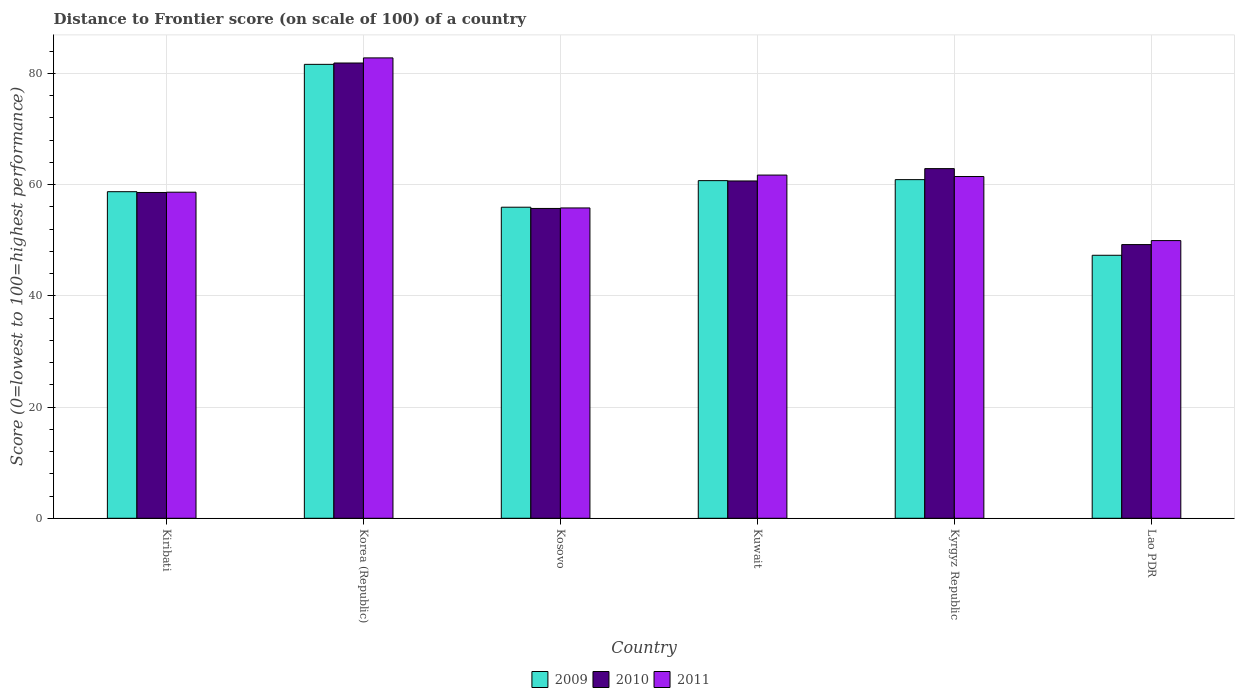How many different coloured bars are there?
Your response must be concise. 3. Are the number of bars per tick equal to the number of legend labels?
Your response must be concise. Yes. Are the number of bars on each tick of the X-axis equal?
Your answer should be very brief. Yes. How many bars are there on the 2nd tick from the left?
Keep it short and to the point. 3. What is the distance to frontier score of in 2011 in Lao PDR?
Your answer should be very brief. 49.93. Across all countries, what is the maximum distance to frontier score of in 2009?
Give a very brief answer. 81.62. Across all countries, what is the minimum distance to frontier score of in 2011?
Offer a very short reply. 49.93. In which country was the distance to frontier score of in 2011 minimum?
Your response must be concise. Lao PDR. What is the total distance to frontier score of in 2009 in the graph?
Provide a short and direct response. 365.16. What is the difference between the distance to frontier score of in 2011 in Kiribati and that in Kuwait?
Your answer should be very brief. -3.08. What is the difference between the distance to frontier score of in 2010 in Lao PDR and the distance to frontier score of in 2009 in Kyrgyz Republic?
Ensure brevity in your answer.  -11.68. What is the average distance to frontier score of in 2009 per country?
Offer a terse response. 60.86. What is the difference between the distance to frontier score of of/in 2009 and distance to frontier score of of/in 2011 in Lao PDR?
Your answer should be very brief. -2.64. In how many countries, is the distance to frontier score of in 2011 greater than 24?
Keep it short and to the point. 6. What is the ratio of the distance to frontier score of in 2010 in Kosovo to that in Kuwait?
Keep it short and to the point. 0.92. Is the distance to frontier score of in 2009 in Kiribati less than that in Kuwait?
Offer a very short reply. Yes. What is the difference between the highest and the second highest distance to frontier score of in 2009?
Give a very brief answer. 20.73. What is the difference between the highest and the lowest distance to frontier score of in 2009?
Give a very brief answer. 34.33. Is the sum of the distance to frontier score of in 2011 in Kiribati and Kyrgyz Republic greater than the maximum distance to frontier score of in 2009 across all countries?
Your answer should be very brief. Yes. What does the 1st bar from the right in Korea (Republic) represents?
Ensure brevity in your answer.  2011. How many countries are there in the graph?
Offer a very short reply. 6. Are the values on the major ticks of Y-axis written in scientific E-notation?
Ensure brevity in your answer.  No. Where does the legend appear in the graph?
Offer a terse response. Bottom center. How many legend labels are there?
Make the answer very short. 3. How are the legend labels stacked?
Ensure brevity in your answer.  Horizontal. What is the title of the graph?
Offer a terse response. Distance to Frontier score (on scale of 100) of a country. What is the label or title of the X-axis?
Offer a very short reply. Country. What is the label or title of the Y-axis?
Provide a succinct answer. Score (0=lowest to 100=highest performance). What is the Score (0=lowest to 100=highest performance) of 2009 in Kiribati?
Provide a short and direct response. 58.72. What is the Score (0=lowest to 100=highest performance) of 2010 in Kiribati?
Your response must be concise. 58.58. What is the Score (0=lowest to 100=highest performance) in 2011 in Kiribati?
Your answer should be compact. 58.63. What is the Score (0=lowest to 100=highest performance) in 2009 in Korea (Republic)?
Offer a very short reply. 81.62. What is the Score (0=lowest to 100=highest performance) of 2010 in Korea (Republic)?
Your response must be concise. 81.86. What is the Score (0=lowest to 100=highest performance) in 2011 in Korea (Republic)?
Your answer should be compact. 82.78. What is the Score (0=lowest to 100=highest performance) in 2009 in Kosovo?
Your response must be concise. 55.93. What is the Score (0=lowest to 100=highest performance) of 2010 in Kosovo?
Make the answer very short. 55.71. What is the Score (0=lowest to 100=highest performance) of 2011 in Kosovo?
Make the answer very short. 55.8. What is the Score (0=lowest to 100=highest performance) in 2009 in Kuwait?
Give a very brief answer. 60.71. What is the Score (0=lowest to 100=highest performance) of 2010 in Kuwait?
Your response must be concise. 60.65. What is the Score (0=lowest to 100=highest performance) of 2011 in Kuwait?
Provide a succinct answer. 61.71. What is the Score (0=lowest to 100=highest performance) in 2009 in Kyrgyz Republic?
Offer a terse response. 60.89. What is the Score (0=lowest to 100=highest performance) in 2010 in Kyrgyz Republic?
Your answer should be compact. 62.87. What is the Score (0=lowest to 100=highest performance) in 2011 in Kyrgyz Republic?
Your answer should be very brief. 61.45. What is the Score (0=lowest to 100=highest performance) of 2009 in Lao PDR?
Make the answer very short. 47.29. What is the Score (0=lowest to 100=highest performance) of 2010 in Lao PDR?
Offer a terse response. 49.21. What is the Score (0=lowest to 100=highest performance) of 2011 in Lao PDR?
Your answer should be very brief. 49.93. Across all countries, what is the maximum Score (0=lowest to 100=highest performance) in 2009?
Your response must be concise. 81.62. Across all countries, what is the maximum Score (0=lowest to 100=highest performance) in 2010?
Your answer should be compact. 81.86. Across all countries, what is the maximum Score (0=lowest to 100=highest performance) of 2011?
Your response must be concise. 82.78. Across all countries, what is the minimum Score (0=lowest to 100=highest performance) in 2009?
Provide a succinct answer. 47.29. Across all countries, what is the minimum Score (0=lowest to 100=highest performance) in 2010?
Ensure brevity in your answer.  49.21. Across all countries, what is the minimum Score (0=lowest to 100=highest performance) of 2011?
Provide a succinct answer. 49.93. What is the total Score (0=lowest to 100=highest performance) of 2009 in the graph?
Offer a terse response. 365.16. What is the total Score (0=lowest to 100=highest performance) in 2010 in the graph?
Ensure brevity in your answer.  368.88. What is the total Score (0=lowest to 100=highest performance) in 2011 in the graph?
Provide a succinct answer. 370.3. What is the difference between the Score (0=lowest to 100=highest performance) in 2009 in Kiribati and that in Korea (Republic)?
Your answer should be compact. -22.9. What is the difference between the Score (0=lowest to 100=highest performance) in 2010 in Kiribati and that in Korea (Republic)?
Offer a terse response. -23.28. What is the difference between the Score (0=lowest to 100=highest performance) in 2011 in Kiribati and that in Korea (Republic)?
Ensure brevity in your answer.  -24.15. What is the difference between the Score (0=lowest to 100=highest performance) in 2009 in Kiribati and that in Kosovo?
Your answer should be compact. 2.79. What is the difference between the Score (0=lowest to 100=highest performance) in 2010 in Kiribati and that in Kosovo?
Provide a short and direct response. 2.87. What is the difference between the Score (0=lowest to 100=highest performance) of 2011 in Kiribati and that in Kosovo?
Ensure brevity in your answer.  2.83. What is the difference between the Score (0=lowest to 100=highest performance) of 2009 in Kiribati and that in Kuwait?
Your response must be concise. -1.99. What is the difference between the Score (0=lowest to 100=highest performance) of 2010 in Kiribati and that in Kuwait?
Keep it short and to the point. -2.07. What is the difference between the Score (0=lowest to 100=highest performance) of 2011 in Kiribati and that in Kuwait?
Your answer should be very brief. -3.08. What is the difference between the Score (0=lowest to 100=highest performance) of 2009 in Kiribati and that in Kyrgyz Republic?
Make the answer very short. -2.17. What is the difference between the Score (0=lowest to 100=highest performance) in 2010 in Kiribati and that in Kyrgyz Republic?
Provide a succinct answer. -4.29. What is the difference between the Score (0=lowest to 100=highest performance) of 2011 in Kiribati and that in Kyrgyz Republic?
Make the answer very short. -2.82. What is the difference between the Score (0=lowest to 100=highest performance) in 2009 in Kiribati and that in Lao PDR?
Offer a terse response. 11.43. What is the difference between the Score (0=lowest to 100=highest performance) of 2010 in Kiribati and that in Lao PDR?
Offer a terse response. 9.37. What is the difference between the Score (0=lowest to 100=highest performance) in 2011 in Kiribati and that in Lao PDR?
Provide a short and direct response. 8.7. What is the difference between the Score (0=lowest to 100=highest performance) in 2009 in Korea (Republic) and that in Kosovo?
Give a very brief answer. 25.69. What is the difference between the Score (0=lowest to 100=highest performance) in 2010 in Korea (Republic) and that in Kosovo?
Your answer should be compact. 26.15. What is the difference between the Score (0=lowest to 100=highest performance) in 2011 in Korea (Republic) and that in Kosovo?
Provide a succinct answer. 26.98. What is the difference between the Score (0=lowest to 100=highest performance) in 2009 in Korea (Republic) and that in Kuwait?
Offer a very short reply. 20.91. What is the difference between the Score (0=lowest to 100=highest performance) of 2010 in Korea (Republic) and that in Kuwait?
Ensure brevity in your answer.  21.21. What is the difference between the Score (0=lowest to 100=highest performance) in 2011 in Korea (Republic) and that in Kuwait?
Make the answer very short. 21.07. What is the difference between the Score (0=lowest to 100=highest performance) in 2009 in Korea (Republic) and that in Kyrgyz Republic?
Ensure brevity in your answer.  20.73. What is the difference between the Score (0=lowest to 100=highest performance) in 2010 in Korea (Republic) and that in Kyrgyz Republic?
Your answer should be very brief. 18.99. What is the difference between the Score (0=lowest to 100=highest performance) of 2011 in Korea (Republic) and that in Kyrgyz Republic?
Give a very brief answer. 21.33. What is the difference between the Score (0=lowest to 100=highest performance) of 2009 in Korea (Republic) and that in Lao PDR?
Your answer should be very brief. 34.33. What is the difference between the Score (0=lowest to 100=highest performance) of 2010 in Korea (Republic) and that in Lao PDR?
Your answer should be very brief. 32.65. What is the difference between the Score (0=lowest to 100=highest performance) in 2011 in Korea (Republic) and that in Lao PDR?
Your answer should be compact. 32.85. What is the difference between the Score (0=lowest to 100=highest performance) of 2009 in Kosovo and that in Kuwait?
Your response must be concise. -4.78. What is the difference between the Score (0=lowest to 100=highest performance) in 2010 in Kosovo and that in Kuwait?
Your answer should be compact. -4.94. What is the difference between the Score (0=lowest to 100=highest performance) in 2011 in Kosovo and that in Kuwait?
Give a very brief answer. -5.91. What is the difference between the Score (0=lowest to 100=highest performance) in 2009 in Kosovo and that in Kyrgyz Republic?
Your answer should be very brief. -4.96. What is the difference between the Score (0=lowest to 100=highest performance) of 2010 in Kosovo and that in Kyrgyz Republic?
Give a very brief answer. -7.16. What is the difference between the Score (0=lowest to 100=highest performance) in 2011 in Kosovo and that in Kyrgyz Republic?
Make the answer very short. -5.65. What is the difference between the Score (0=lowest to 100=highest performance) of 2009 in Kosovo and that in Lao PDR?
Provide a succinct answer. 8.64. What is the difference between the Score (0=lowest to 100=highest performance) in 2011 in Kosovo and that in Lao PDR?
Provide a short and direct response. 5.87. What is the difference between the Score (0=lowest to 100=highest performance) in 2009 in Kuwait and that in Kyrgyz Republic?
Offer a terse response. -0.18. What is the difference between the Score (0=lowest to 100=highest performance) of 2010 in Kuwait and that in Kyrgyz Republic?
Your answer should be very brief. -2.22. What is the difference between the Score (0=lowest to 100=highest performance) of 2011 in Kuwait and that in Kyrgyz Republic?
Ensure brevity in your answer.  0.26. What is the difference between the Score (0=lowest to 100=highest performance) of 2009 in Kuwait and that in Lao PDR?
Ensure brevity in your answer.  13.42. What is the difference between the Score (0=lowest to 100=highest performance) of 2010 in Kuwait and that in Lao PDR?
Your answer should be compact. 11.44. What is the difference between the Score (0=lowest to 100=highest performance) in 2011 in Kuwait and that in Lao PDR?
Your answer should be very brief. 11.78. What is the difference between the Score (0=lowest to 100=highest performance) in 2009 in Kyrgyz Republic and that in Lao PDR?
Provide a succinct answer. 13.6. What is the difference between the Score (0=lowest to 100=highest performance) of 2010 in Kyrgyz Republic and that in Lao PDR?
Provide a short and direct response. 13.66. What is the difference between the Score (0=lowest to 100=highest performance) of 2011 in Kyrgyz Republic and that in Lao PDR?
Offer a terse response. 11.52. What is the difference between the Score (0=lowest to 100=highest performance) of 2009 in Kiribati and the Score (0=lowest to 100=highest performance) of 2010 in Korea (Republic)?
Your response must be concise. -23.14. What is the difference between the Score (0=lowest to 100=highest performance) of 2009 in Kiribati and the Score (0=lowest to 100=highest performance) of 2011 in Korea (Republic)?
Give a very brief answer. -24.06. What is the difference between the Score (0=lowest to 100=highest performance) in 2010 in Kiribati and the Score (0=lowest to 100=highest performance) in 2011 in Korea (Republic)?
Provide a succinct answer. -24.2. What is the difference between the Score (0=lowest to 100=highest performance) of 2009 in Kiribati and the Score (0=lowest to 100=highest performance) of 2010 in Kosovo?
Give a very brief answer. 3.01. What is the difference between the Score (0=lowest to 100=highest performance) of 2009 in Kiribati and the Score (0=lowest to 100=highest performance) of 2011 in Kosovo?
Offer a terse response. 2.92. What is the difference between the Score (0=lowest to 100=highest performance) in 2010 in Kiribati and the Score (0=lowest to 100=highest performance) in 2011 in Kosovo?
Give a very brief answer. 2.78. What is the difference between the Score (0=lowest to 100=highest performance) of 2009 in Kiribati and the Score (0=lowest to 100=highest performance) of 2010 in Kuwait?
Make the answer very short. -1.93. What is the difference between the Score (0=lowest to 100=highest performance) in 2009 in Kiribati and the Score (0=lowest to 100=highest performance) in 2011 in Kuwait?
Your response must be concise. -2.99. What is the difference between the Score (0=lowest to 100=highest performance) of 2010 in Kiribati and the Score (0=lowest to 100=highest performance) of 2011 in Kuwait?
Offer a very short reply. -3.13. What is the difference between the Score (0=lowest to 100=highest performance) of 2009 in Kiribati and the Score (0=lowest to 100=highest performance) of 2010 in Kyrgyz Republic?
Make the answer very short. -4.15. What is the difference between the Score (0=lowest to 100=highest performance) of 2009 in Kiribati and the Score (0=lowest to 100=highest performance) of 2011 in Kyrgyz Republic?
Make the answer very short. -2.73. What is the difference between the Score (0=lowest to 100=highest performance) of 2010 in Kiribati and the Score (0=lowest to 100=highest performance) of 2011 in Kyrgyz Republic?
Your answer should be compact. -2.87. What is the difference between the Score (0=lowest to 100=highest performance) in 2009 in Kiribati and the Score (0=lowest to 100=highest performance) in 2010 in Lao PDR?
Offer a very short reply. 9.51. What is the difference between the Score (0=lowest to 100=highest performance) in 2009 in Kiribati and the Score (0=lowest to 100=highest performance) in 2011 in Lao PDR?
Provide a succinct answer. 8.79. What is the difference between the Score (0=lowest to 100=highest performance) in 2010 in Kiribati and the Score (0=lowest to 100=highest performance) in 2011 in Lao PDR?
Keep it short and to the point. 8.65. What is the difference between the Score (0=lowest to 100=highest performance) of 2009 in Korea (Republic) and the Score (0=lowest to 100=highest performance) of 2010 in Kosovo?
Provide a succinct answer. 25.91. What is the difference between the Score (0=lowest to 100=highest performance) in 2009 in Korea (Republic) and the Score (0=lowest to 100=highest performance) in 2011 in Kosovo?
Provide a succinct answer. 25.82. What is the difference between the Score (0=lowest to 100=highest performance) of 2010 in Korea (Republic) and the Score (0=lowest to 100=highest performance) of 2011 in Kosovo?
Keep it short and to the point. 26.06. What is the difference between the Score (0=lowest to 100=highest performance) in 2009 in Korea (Republic) and the Score (0=lowest to 100=highest performance) in 2010 in Kuwait?
Your response must be concise. 20.97. What is the difference between the Score (0=lowest to 100=highest performance) in 2009 in Korea (Republic) and the Score (0=lowest to 100=highest performance) in 2011 in Kuwait?
Offer a very short reply. 19.91. What is the difference between the Score (0=lowest to 100=highest performance) of 2010 in Korea (Republic) and the Score (0=lowest to 100=highest performance) of 2011 in Kuwait?
Provide a succinct answer. 20.15. What is the difference between the Score (0=lowest to 100=highest performance) in 2009 in Korea (Republic) and the Score (0=lowest to 100=highest performance) in 2010 in Kyrgyz Republic?
Your answer should be compact. 18.75. What is the difference between the Score (0=lowest to 100=highest performance) of 2009 in Korea (Republic) and the Score (0=lowest to 100=highest performance) of 2011 in Kyrgyz Republic?
Your response must be concise. 20.17. What is the difference between the Score (0=lowest to 100=highest performance) in 2010 in Korea (Republic) and the Score (0=lowest to 100=highest performance) in 2011 in Kyrgyz Republic?
Your answer should be very brief. 20.41. What is the difference between the Score (0=lowest to 100=highest performance) in 2009 in Korea (Republic) and the Score (0=lowest to 100=highest performance) in 2010 in Lao PDR?
Provide a short and direct response. 32.41. What is the difference between the Score (0=lowest to 100=highest performance) of 2009 in Korea (Republic) and the Score (0=lowest to 100=highest performance) of 2011 in Lao PDR?
Provide a short and direct response. 31.69. What is the difference between the Score (0=lowest to 100=highest performance) in 2010 in Korea (Republic) and the Score (0=lowest to 100=highest performance) in 2011 in Lao PDR?
Your response must be concise. 31.93. What is the difference between the Score (0=lowest to 100=highest performance) in 2009 in Kosovo and the Score (0=lowest to 100=highest performance) in 2010 in Kuwait?
Provide a succinct answer. -4.72. What is the difference between the Score (0=lowest to 100=highest performance) of 2009 in Kosovo and the Score (0=lowest to 100=highest performance) of 2011 in Kuwait?
Ensure brevity in your answer.  -5.78. What is the difference between the Score (0=lowest to 100=highest performance) of 2009 in Kosovo and the Score (0=lowest to 100=highest performance) of 2010 in Kyrgyz Republic?
Offer a terse response. -6.94. What is the difference between the Score (0=lowest to 100=highest performance) in 2009 in Kosovo and the Score (0=lowest to 100=highest performance) in 2011 in Kyrgyz Republic?
Your answer should be compact. -5.52. What is the difference between the Score (0=lowest to 100=highest performance) of 2010 in Kosovo and the Score (0=lowest to 100=highest performance) of 2011 in Kyrgyz Republic?
Offer a terse response. -5.74. What is the difference between the Score (0=lowest to 100=highest performance) in 2009 in Kosovo and the Score (0=lowest to 100=highest performance) in 2010 in Lao PDR?
Offer a very short reply. 6.72. What is the difference between the Score (0=lowest to 100=highest performance) in 2009 in Kosovo and the Score (0=lowest to 100=highest performance) in 2011 in Lao PDR?
Give a very brief answer. 6. What is the difference between the Score (0=lowest to 100=highest performance) of 2010 in Kosovo and the Score (0=lowest to 100=highest performance) of 2011 in Lao PDR?
Offer a terse response. 5.78. What is the difference between the Score (0=lowest to 100=highest performance) of 2009 in Kuwait and the Score (0=lowest to 100=highest performance) of 2010 in Kyrgyz Republic?
Ensure brevity in your answer.  -2.16. What is the difference between the Score (0=lowest to 100=highest performance) of 2009 in Kuwait and the Score (0=lowest to 100=highest performance) of 2011 in Kyrgyz Republic?
Keep it short and to the point. -0.74. What is the difference between the Score (0=lowest to 100=highest performance) of 2009 in Kuwait and the Score (0=lowest to 100=highest performance) of 2011 in Lao PDR?
Offer a very short reply. 10.78. What is the difference between the Score (0=lowest to 100=highest performance) in 2010 in Kuwait and the Score (0=lowest to 100=highest performance) in 2011 in Lao PDR?
Keep it short and to the point. 10.72. What is the difference between the Score (0=lowest to 100=highest performance) in 2009 in Kyrgyz Republic and the Score (0=lowest to 100=highest performance) in 2010 in Lao PDR?
Ensure brevity in your answer.  11.68. What is the difference between the Score (0=lowest to 100=highest performance) in 2009 in Kyrgyz Republic and the Score (0=lowest to 100=highest performance) in 2011 in Lao PDR?
Offer a very short reply. 10.96. What is the difference between the Score (0=lowest to 100=highest performance) of 2010 in Kyrgyz Republic and the Score (0=lowest to 100=highest performance) of 2011 in Lao PDR?
Provide a succinct answer. 12.94. What is the average Score (0=lowest to 100=highest performance) of 2009 per country?
Provide a succinct answer. 60.86. What is the average Score (0=lowest to 100=highest performance) in 2010 per country?
Provide a succinct answer. 61.48. What is the average Score (0=lowest to 100=highest performance) of 2011 per country?
Your response must be concise. 61.72. What is the difference between the Score (0=lowest to 100=highest performance) of 2009 and Score (0=lowest to 100=highest performance) of 2010 in Kiribati?
Your answer should be compact. 0.14. What is the difference between the Score (0=lowest to 100=highest performance) in 2009 and Score (0=lowest to 100=highest performance) in 2011 in Kiribati?
Offer a terse response. 0.09. What is the difference between the Score (0=lowest to 100=highest performance) of 2010 and Score (0=lowest to 100=highest performance) of 2011 in Kiribati?
Make the answer very short. -0.05. What is the difference between the Score (0=lowest to 100=highest performance) of 2009 and Score (0=lowest to 100=highest performance) of 2010 in Korea (Republic)?
Ensure brevity in your answer.  -0.24. What is the difference between the Score (0=lowest to 100=highest performance) in 2009 and Score (0=lowest to 100=highest performance) in 2011 in Korea (Republic)?
Your answer should be very brief. -1.16. What is the difference between the Score (0=lowest to 100=highest performance) in 2010 and Score (0=lowest to 100=highest performance) in 2011 in Korea (Republic)?
Ensure brevity in your answer.  -0.92. What is the difference between the Score (0=lowest to 100=highest performance) in 2009 and Score (0=lowest to 100=highest performance) in 2010 in Kosovo?
Your answer should be compact. 0.22. What is the difference between the Score (0=lowest to 100=highest performance) in 2009 and Score (0=lowest to 100=highest performance) in 2011 in Kosovo?
Give a very brief answer. 0.13. What is the difference between the Score (0=lowest to 100=highest performance) in 2010 and Score (0=lowest to 100=highest performance) in 2011 in Kosovo?
Provide a succinct answer. -0.09. What is the difference between the Score (0=lowest to 100=highest performance) in 2009 and Score (0=lowest to 100=highest performance) in 2010 in Kuwait?
Offer a very short reply. 0.06. What is the difference between the Score (0=lowest to 100=highest performance) of 2010 and Score (0=lowest to 100=highest performance) of 2011 in Kuwait?
Your answer should be very brief. -1.06. What is the difference between the Score (0=lowest to 100=highest performance) in 2009 and Score (0=lowest to 100=highest performance) in 2010 in Kyrgyz Republic?
Offer a terse response. -1.98. What is the difference between the Score (0=lowest to 100=highest performance) in 2009 and Score (0=lowest to 100=highest performance) in 2011 in Kyrgyz Republic?
Make the answer very short. -0.56. What is the difference between the Score (0=lowest to 100=highest performance) in 2010 and Score (0=lowest to 100=highest performance) in 2011 in Kyrgyz Republic?
Your answer should be compact. 1.42. What is the difference between the Score (0=lowest to 100=highest performance) in 2009 and Score (0=lowest to 100=highest performance) in 2010 in Lao PDR?
Your answer should be very brief. -1.92. What is the difference between the Score (0=lowest to 100=highest performance) of 2009 and Score (0=lowest to 100=highest performance) of 2011 in Lao PDR?
Offer a very short reply. -2.64. What is the difference between the Score (0=lowest to 100=highest performance) of 2010 and Score (0=lowest to 100=highest performance) of 2011 in Lao PDR?
Keep it short and to the point. -0.72. What is the ratio of the Score (0=lowest to 100=highest performance) in 2009 in Kiribati to that in Korea (Republic)?
Keep it short and to the point. 0.72. What is the ratio of the Score (0=lowest to 100=highest performance) in 2010 in Kiribati to that in Korea (Republic)?
Your answer should be compact. 0.72. What is the ratio of the Score (0=lowest to 100=highest performance) of 2011 in Kiribati to that in Korea (Republic)?
Your answer should be very brief. 0.71. What is the ratio of the Score (0=lowest to 100=highest performance) of 2009 in Kiribati to that in Kosovo?
Offer a terse response. 1.05. What is the ratio of the Score (0=lowest to 100=highest performance) of 2010 in Kiribati to that in Kosovo?
Your answer should be compact. 1.05. What is the ratio of the Score (0=lowest to 100=highest performance) in 2011 in Kiribati to that in Kosovo?
Your response must be concise. 1.05. What is the ratio of the Score (0=lowest to 100=highest performance) of 2009 in Kiribati to that in Kuwait?
Offer a terse response. 0.97. What is the ratio of the Score (0=lowest to 100=highest performance) in 2010 in Kiribati to that in Kuwait?
Give a very brief answer. 0.97. What is the ratio of the Score (0=lowest to 100=highest performance) of 2011 in Kiribati to that in Kuwait?
Provide a succinct answer. 0.95. What is the ratio of the Score (0=lowest to 100=highest performance) in 2009 in Kiribati to that in Kyrgyz Republic?
Give a very brief answer. 0.96. What is the ratio of the Score (0=lowest to 100=highest performance) in 2010 in Kiribati to that in Kyrgyz Republic?
Your answer should be very brief. 0.93. What is the ratio of the Score (0=lowest to 100=highest performance) of 2011 in Kiribati to that in Kyrgyz Republic?
Give a very brief answer. 0.95. What is the ratio of the Score (0=lowest to 100=highest performance) in 2009 in Kiribati to that in Lao PDR?
Provide a short and direct response. 1.24. What is the ratio of the Score (0=lowest to 100=highest performance) in 2010 in Kiribati to that in Lao PDR?
Offer a very short reply. 1.19. What is the ratio of the Score (0=lowest to 100=highest performance) in 2011 in Kiribati to that in Lao PDR?
Make the answer very short. 1.17. What is the ratio of the Score (0=lowest to 100=highest performance) in 2009 in Korea (Republic) to that in Kosovo?
Provide a succinct answer. 1.46. What is the ratio of the Score (0=lowest to 100=highest performance) of 2010 in Korea (Republic) to that in Kosovo?
Provide a short and direct response. 1.47. What is the ratio of the Score (0=lowest to 100=highest performance) in 2011 in Korea (Republic) to that in Kosovo?
Your answer should be compact. 1.48. What is the ratio of the Score (0=lowest to 100=highest performance) in 2009 in Korea (Republic) to that in Kuwait?
Provide a succinct answer. 1.34. What is the ratio of the Score (0=lowest to 100=highest performance) of 2010 in Korea (Republic) to that in Kuwait?
Give a very brief answer. 1.35. What is the ratio of the Score (0=lowest to 100=highest performance) of 2011 in Korea (Republic) to that in Kuwait?
Offer a very short reply. 1.34. What is the ratio of the Score (0=lowest to 100=highest performance) of 2009 in Korea (Republic) to that in Kyrgyz Republic?
Your answer should be very brief. 1.34. What is the ratio of the Score (0=lowest to 100=highest performance) of 2010 in Korea (Republic) to that in Kyrgyz Republic?
Make the answer very short. 1.3. What is the ratio of the Score (0=lowest to 100=highest performance) of 2011 in Korea (Republic) to that in Kyrgyz Republic?
Your answer should be compact. 1.35. What is the ratio of the Score (0=lowest to 100=highest performance) of 2009 in Korea (Republic) to that in Lao PDR?
Offer a very short reply. 1.73. What is the ratio of the Score (0=lowest to 100=highest performance) of 2010 in Korea (Republic) to that in Lao PDR?
Your answer should be very brief. 1.66. What is the ratio of the Score (0=lowest to 100=highest performance) of 2011 in Korea (Republic) to that in Lao PDR?
Your response must be concise. 1.66. What is the ratio of the Score (0=lowest to 100=highest performance) in 2009 in Kosovo to that in Kuwait?
Offer a terse response. 0.92. What is the ratio of the Score (0=lowest to 100=highest performance) in 2010 in Kosovo to that in Kuwait?
Make the answer very short. 0.92. What is the ratio of the Score (0=lowest to 100=highest performance) of 2011 in Kosovo to that in Kuwait?
Give a very brief answer. 0.9. What is the ratio of the Score (0=lowest to 100=highest performance) of 2009 in Kosovo to that in Kyrgyz Republic?
Provide a succinct answer. 0.92. What is the ratio of the Score (0=lowest to 100=highest performance) in 2010 in Kosovo to that in Kyrgyz Republic?
Provide a short and direct response. 0.89. What is the ratio of the Score (0=lowest to 100=highest performance) of 2011 in Kosovo to that in Kyrgyz Republic?
Offer a terse response. 0.91. What is the ratio of the Score (0=lowest to 100=highest performance) of 2009 in Kosovo to that in Lao PDR?
Your answer should be very brief. 1.18. What is the ratio of the Score (0=lowest to 100=highest performance) of 2010 in Kosovo to that in Lao PDR?
Provide a succinct answer. 1.13. What is the ratio of the Score (0=lowest to 100=highest performance) of 2011 in Kosovo to that in Lao PDR?
Offer a terse response. 1.12. What is the ratio of the Score (0=lowest to 100=highest performance) of 2009 in Kuwait to that in Kyrgyz Republic?
Provide a short and direct response. 1. What is the ratio of the Score (0=lowest to 100=highest performance) in 2010 in Kuwait to that in Kyrgyz Republic?
Offer a very short reply. 0.96. What is the ratio of the Score (0=lowest to 100=highest performance) in 2009 in Kuwait to that in Lao PDR?
Provide a succinct answer. 1.28. What is the ratio of the Score (0=lowest to 100=highest performance) of 2010 in Kuwait to that in Lao PDR?
Provide a succinct answer. 1.23. What is the ratio of the Score (0=lowest to 100=highest performance) in 2011 in Kuwait to that in Lao PDR?
Ensure brevity in your answer.  1.24. What is the ratio of the Score (0=lowest to 100=highest performance) of 2009 in Kyrgyz Republic to that in Lao PDR?
Ensure brevity in your answer.  1.29. What is the ratio of the Score (0=lowest to 100=highest performance) of 2010 in Kyrgyz Republic to that in Lao PDR?
Keep it short and to the point. 1.28. What is the ratio of the Score (0=lowest to 100=highest performance) in 2011 in Kyrgyz Republic to that in Lao PDR?
Offer a very short reply. 1.23. What is the difference between the highest and the second highest Score (0=lowest to 100=highest performance) of 2009?
Offer a very short reply. 20.73. What is the difference between the highest and the second highest Score (0=lowest to 100=highest performance) of 2010?
Keep it short and to the point. 18.99. What is the difference between the highest and the second highest Score (0=lowest to 100=highest performance) in 2011?
Make the answer very short. 21.07. What is the difference between the highest and the lowest Score (0=lowest to 100=highest performance) of 2009?
Your answer should be very brief. 34.33. What is the difference between the highest and the lowest Score (0=lowest to 100=highest performance) in 2010?
Ensure brevity in your answer.  32.65. What is the difference between the highest and the lowest Score (0=lowest to 100=highest performance) of 2011?
Give a very brief answer. 32.85. 